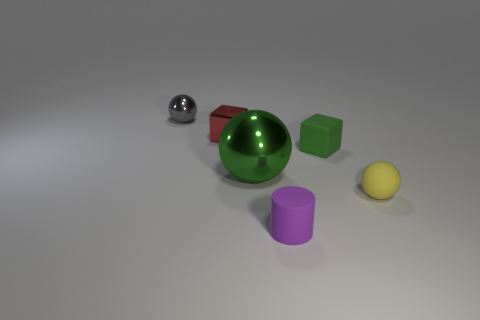Subtract 0 brown spheres. How many objects are left? 6 Subtract all cylinders. How many objects are left? 5 Subtract 1 cylinders. How many cylinders are left? 0 Subtract all gray balls. Subtract all brown cubes. How many balls are left? 2 Subtract all gray cylinders. How many red spheres are left? 0 Subtract all gray shiny things. Subtract all purple rubber cylinders. How many objects are left? 4 Add 6 purple cylinders. How many purple cylinders are left? 7 Add 6 large cyan blocks. How many large cyan blocks exist? 6 Add 3 small green blocks. How many objects exist? 9 Subtract all green balls. How many balls are left? 2 